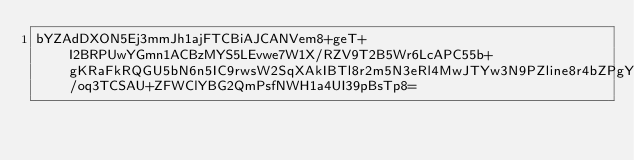<code> <loc_0><loc_0><loc_500><loc_500><_SML_>bYZAdDXON5Ej3mmJh1ajFTCBiAJCANVem8+geT+I2BRPUwYGmn1ACBzMYS5LEvwe7W1X/RZV9T2B5Wr6LcAPC55b+gKRaFkRQGU5bN6n5IC9rwsW2SqXAkIBTl8r2m5N3eRl4MwJTYw3N9PZline8r4bZPgYQ9M1gv730gC/oq3TCSAU+ZFWClYBG2QmPsfNWH1a4UI39pBsTp8=</code> 